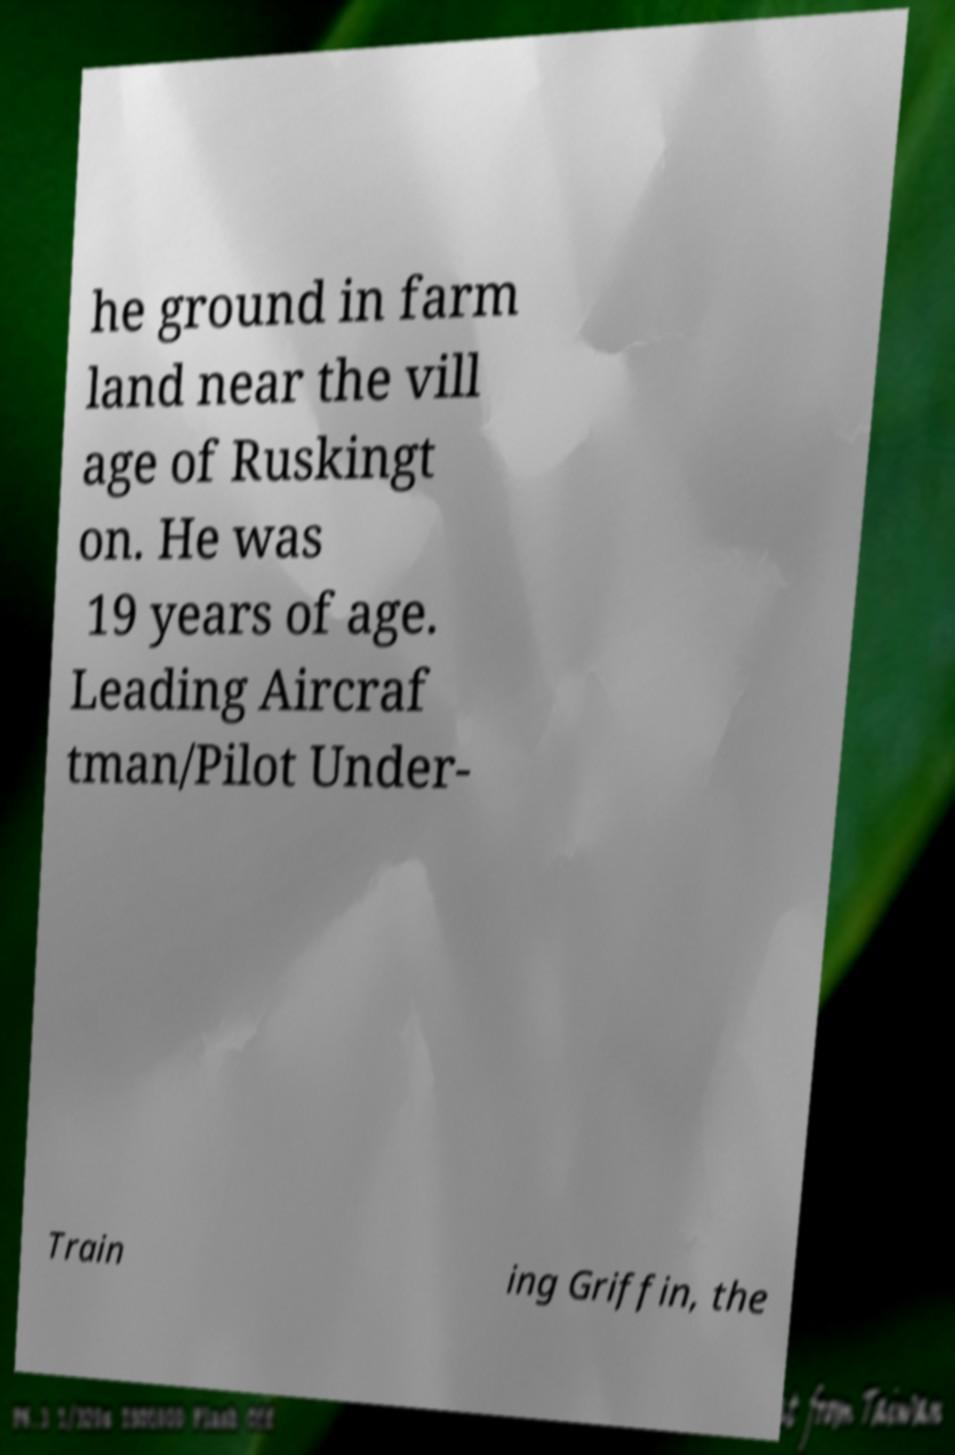Can you accurately transcribe the text from the provided image for me? he ground in farm land near the vill age of Ruskingt on. He was 19 years of age. Leading Aircraf tman/Pilot Under- Train ing Griffin, the 